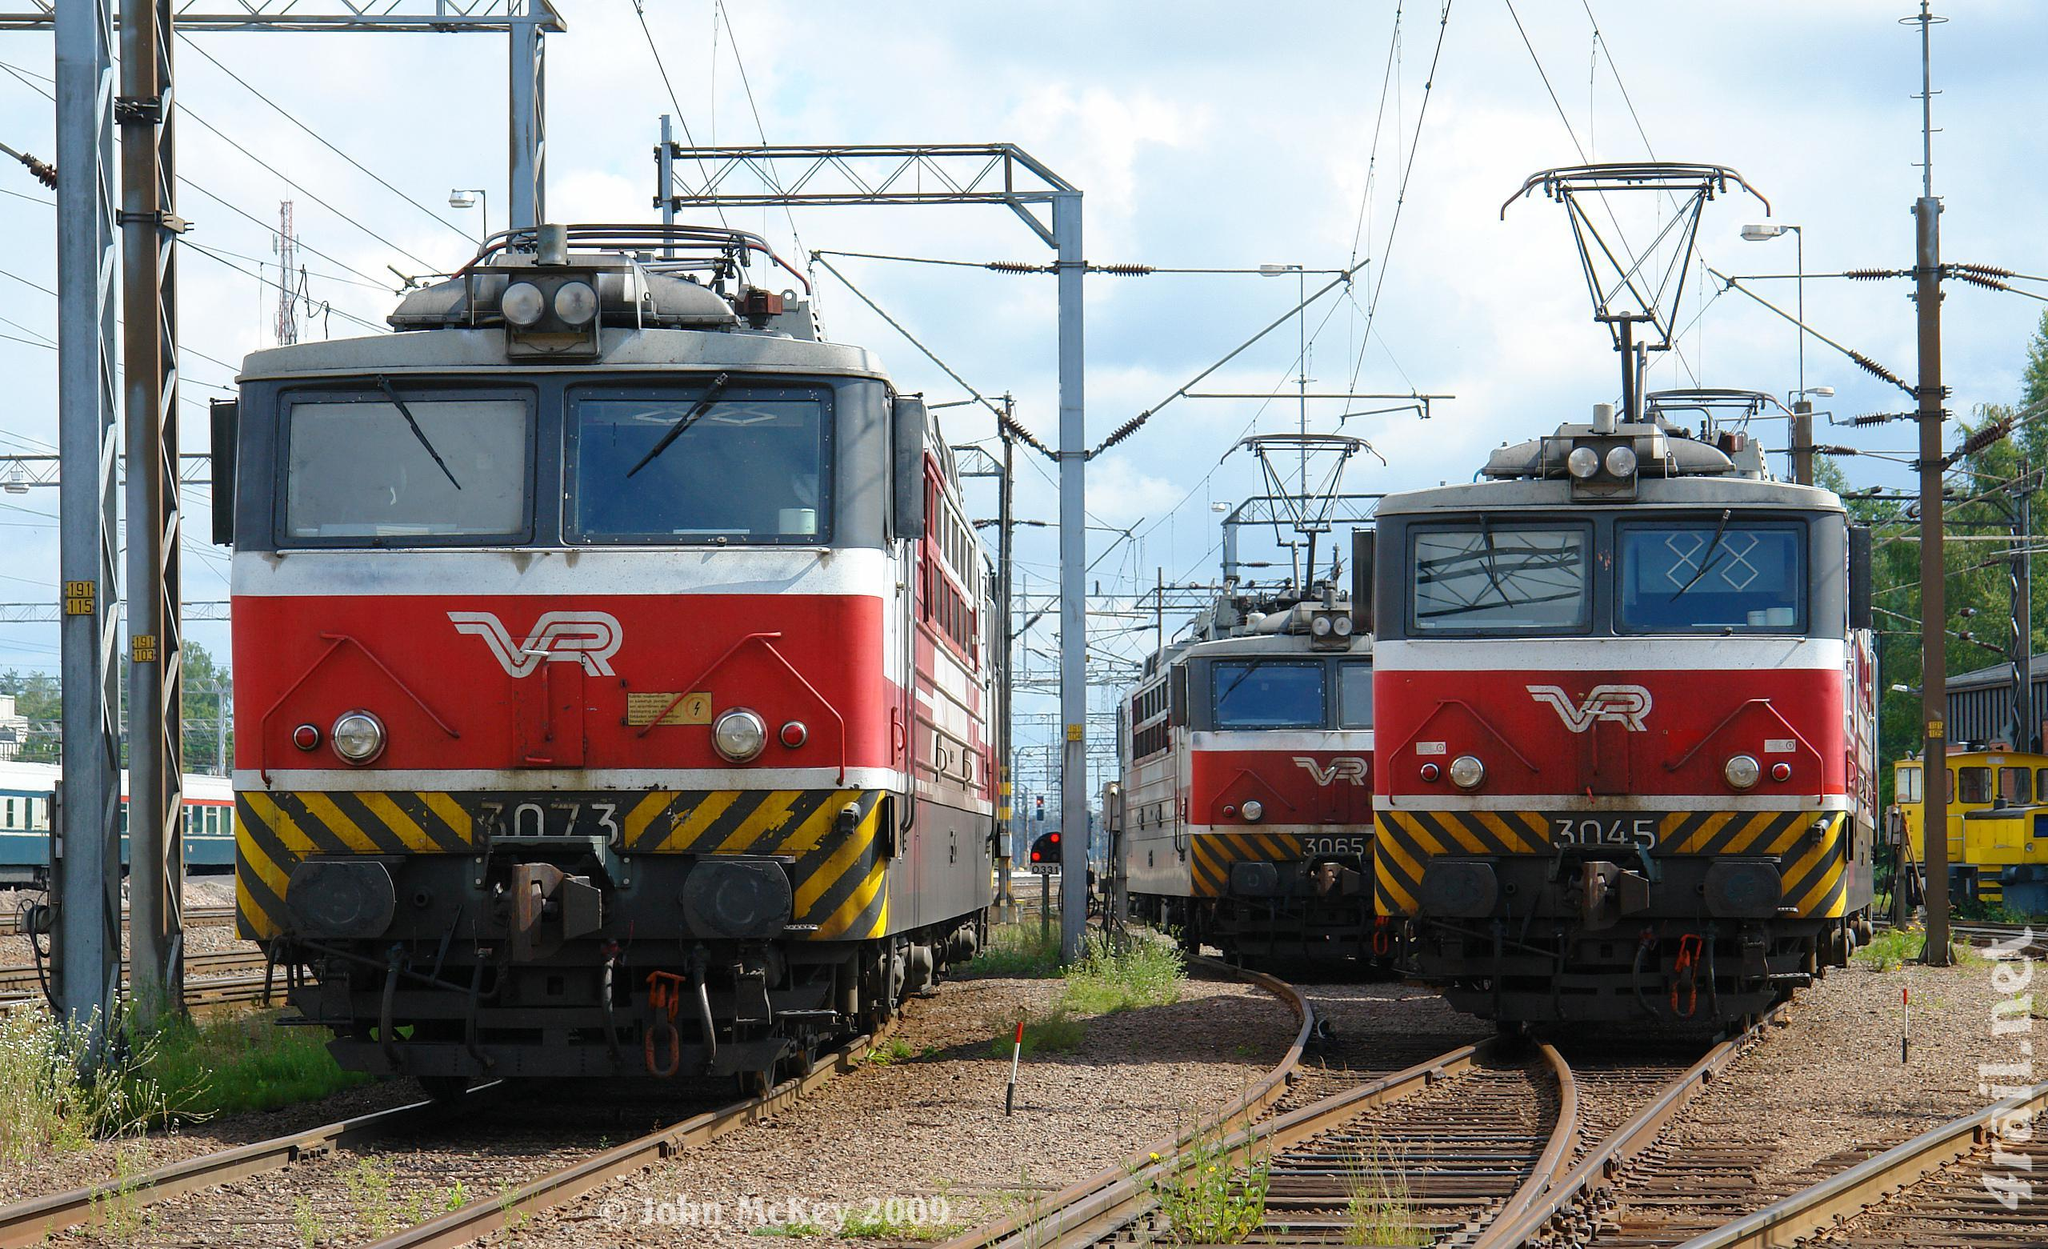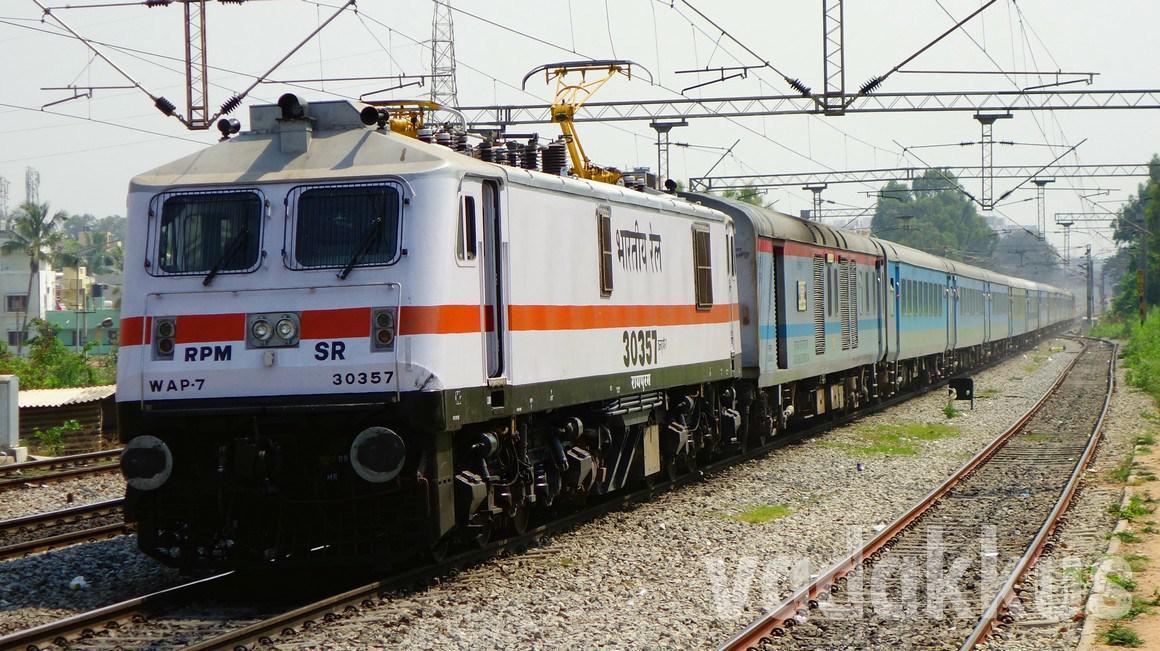The first image is the image on the left, the second image is the image on the right. Examine the images to the left and right. Is the description "Exactly two trains are angled in the same direction." accurate? Answer yes or no. No. The first image is the image on the left, the second image is the image on the right. Assess this claim about the two images: "The train in the image on the right has at least one full length red stripe.". Correct or not? Answer yes or no. Yes. 